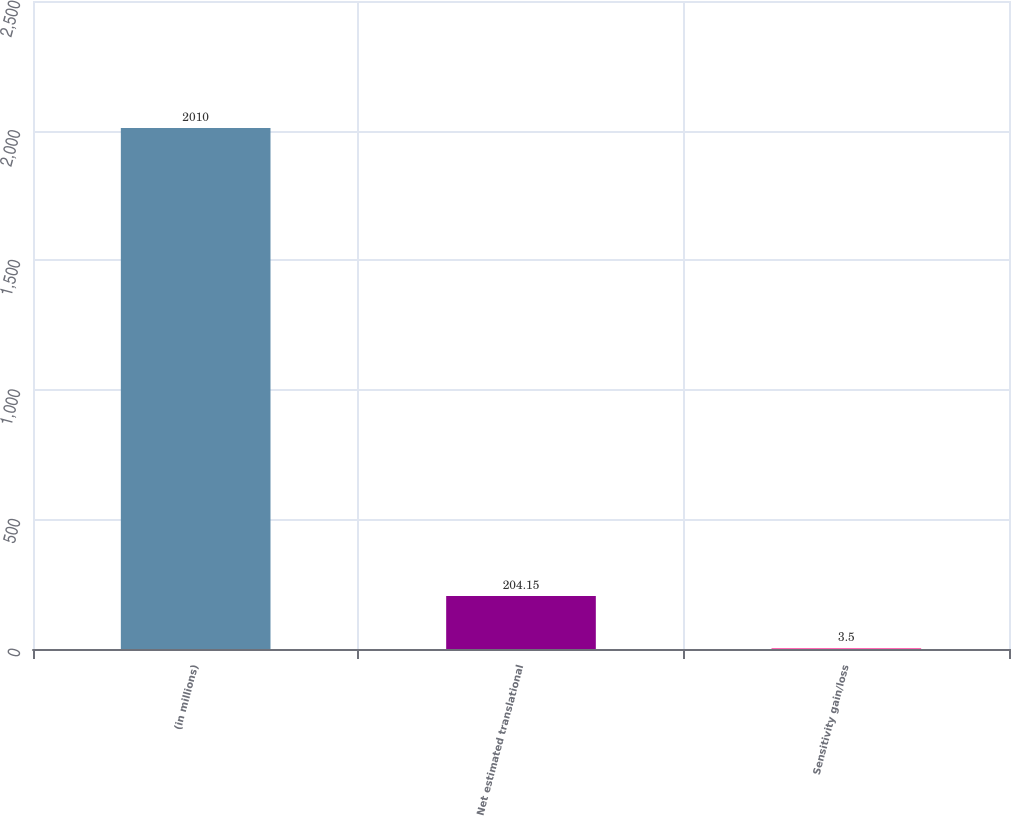Convert chart to OTSL. <chart><loc_0><loc_0><loc_500><loc_500><bar_chart><fcel>(in millions)<fcel>Net estimated translational<fcel>Sensitivity gain/loss<nl><fcel>2010<fcel>204.15<fcel>3.5<nl></chart> 